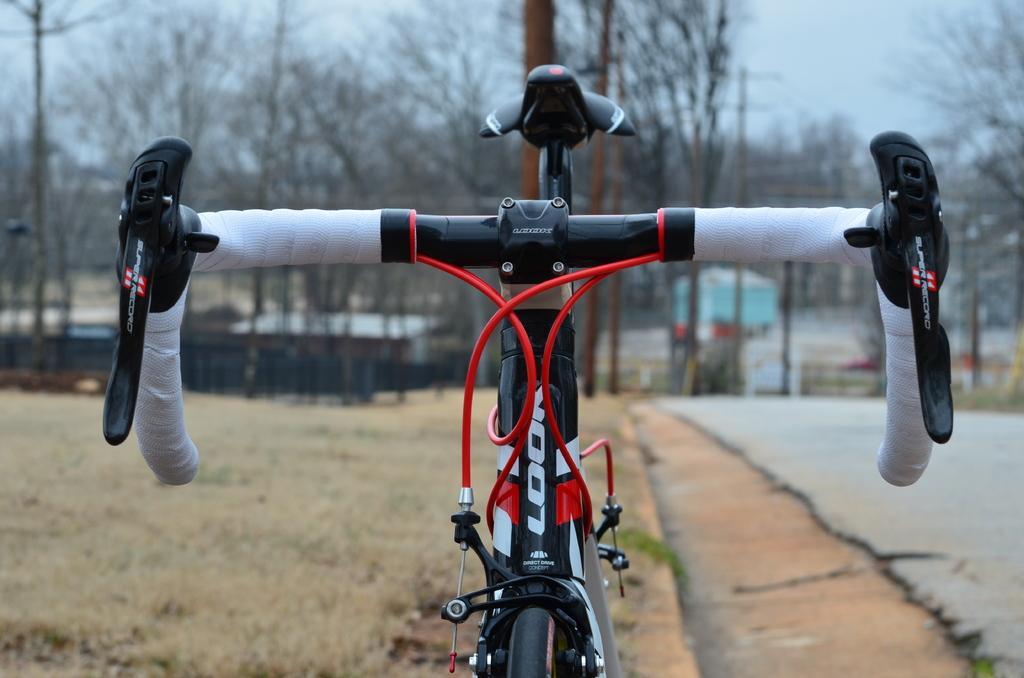Can you describe this image briefly? Here in this picture we can see a bicycle present on the ground, which is fully covered with grass over there and behind that we can see trees and sheds present in the far over there. 